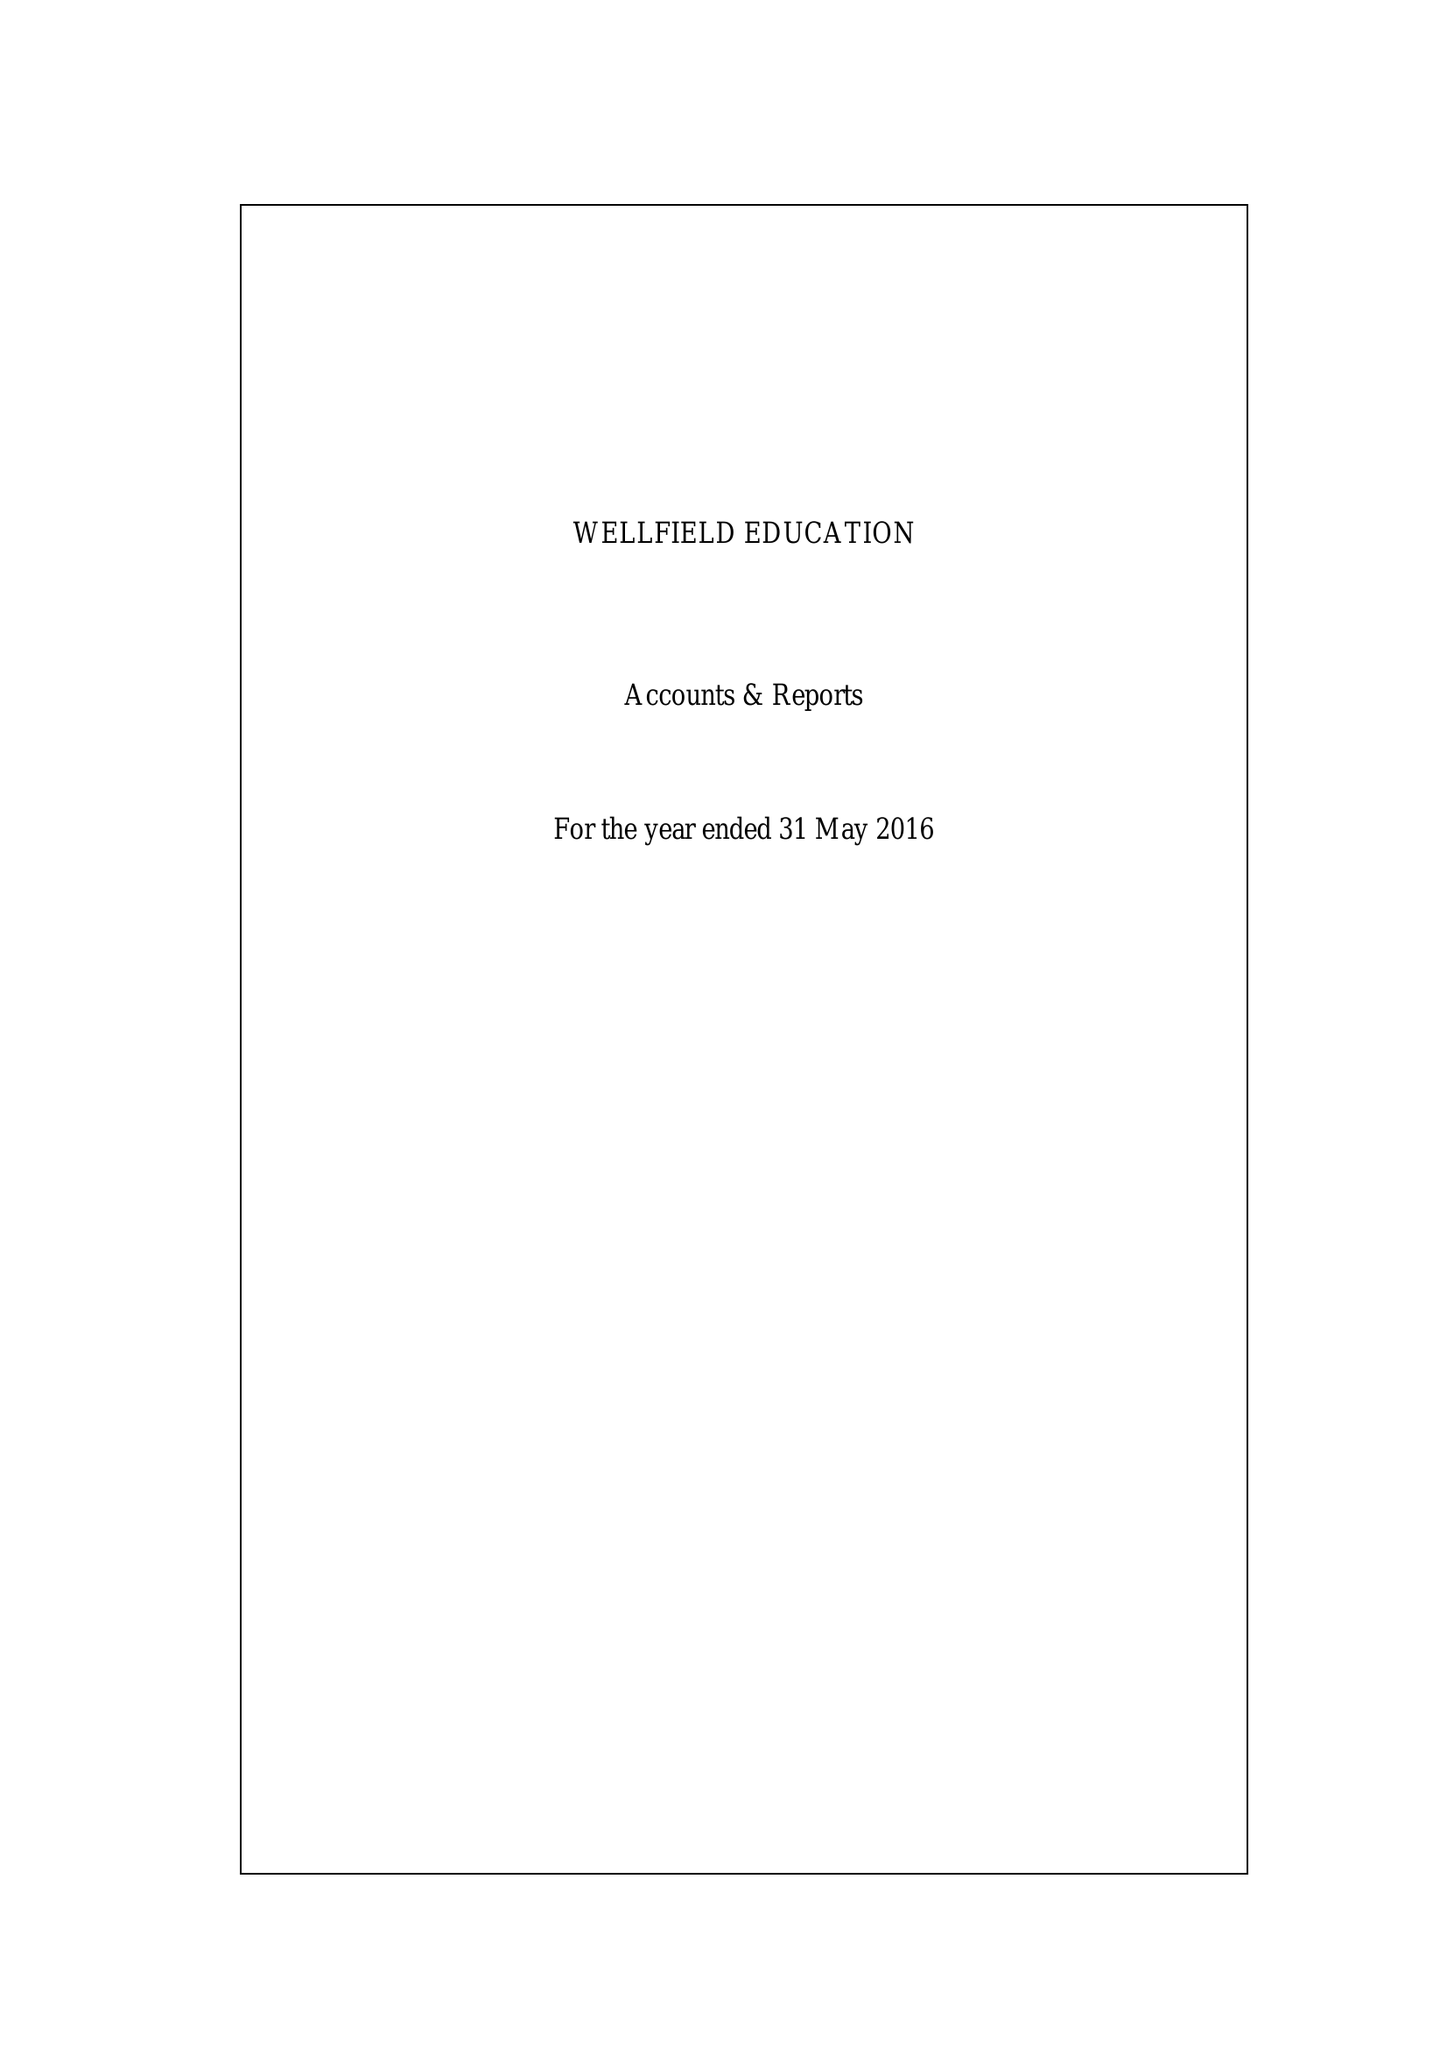What is the value for the address__street_line?
Answer the question using a single word or phrase. 266/268 STREATHAM HIGH ROAD 